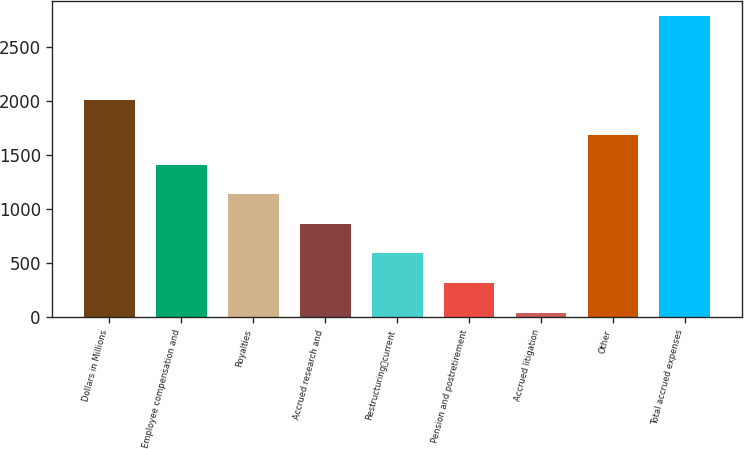<chart> <loc_0><loc_0><loc_500><loc_500><bar_chart><fcel>Dollars in Millions<fcel>Employee compensation and<fcel>Royalties<fcel>Accrued research and<fcel>Restructuringcurrent<fcel>Pension and postretirement<fcel>Accrued litigation<fcel>Other<fcel>Total accrued expenses<nl><fcel>2009<fcel>1412<fcel>1137.4<fcel>862.8<fcel>588.2<fcel>313.6<fcel>39<fcel>1686.6<fcel>2785<nl></chart> 